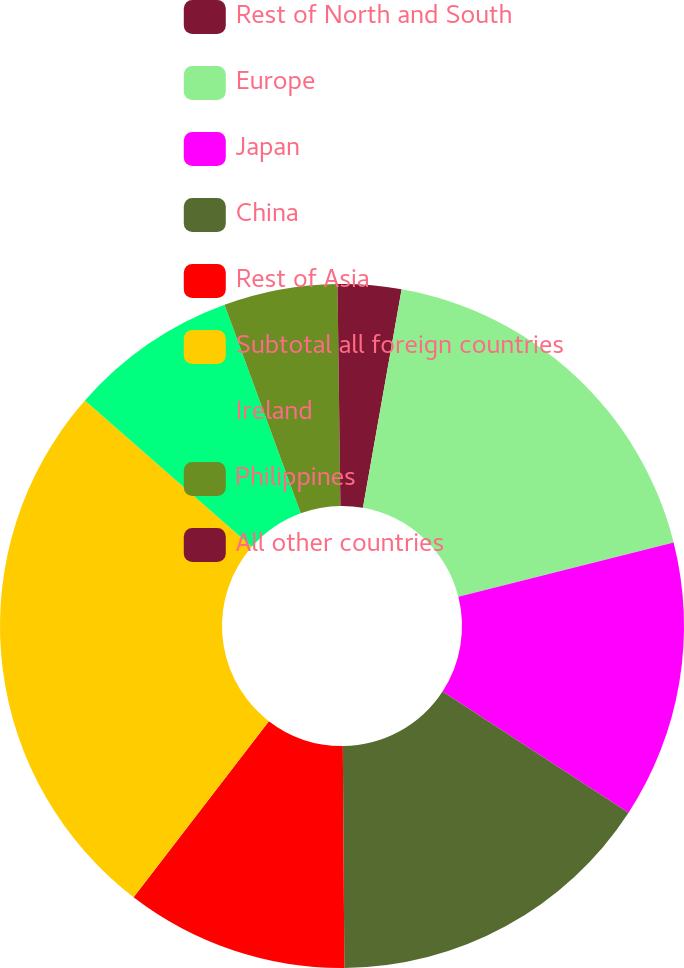Convert chart to OTSL. <chart><loc_0><loc_0><loc_500><loc_500><pie_chart><fcel>Rest of North and South<fcel>Europe<fcel>Japan<fcel>China<fcel>Rest of Asia<fcel>Subtotal all foreign countries<fcel>Ireland<fcel>Philippines<fcel>All other countries<nl><fcel>2.79%<fcel>18.28%<fcel>13.12%<fcel>15.7%<fcel>10.54%<fcel>26.03%<fcel>7.96%<fcel>5.37%<fcel>0.21%<nl></chart> 